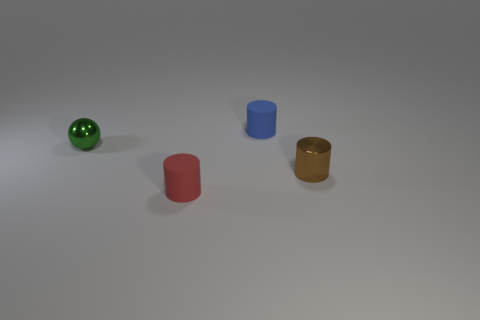How many things are tiny brown objects or rubber cylinders?
Offer a very short reply. 3. The rubber object behind the small red object that is in front of the tiny cylinder that is behind the brown cylinder is what color?
Make the answer very short. Blue. What color is the metal cylinder?
Offer a very short reply. Brown. Is the number of tiny cylinders that are to the left of the green metal object greater than the number of things that are in front of the blue rubber object?
Give a very brief answer. No. There is a blue thing; is its shape the same as the small metallic thing on the left side of the tiny red object?
Give a very brief answer. No. Are there any tiny blue cylinders to the right of the tiny thing that is on the left side of the matte cylinder that is in front of the small green metal thing?
Offer a very short reply. Yes. Are there fewer shiny cylinders that are behind the tiny blue rubber object than tiny cylinders that are in front of the green sphere?
Offer a very short reply. Yes. What is the shape of the small brown object that is made of the same material as the small ball?
Make the answer very short. Cylinder. There is a cylinder on the right side of the small matte thing behind the metal thing that is on the right side of the small red object; what size is it?
Your response must be concise. Small. Are there more green shiny objects than metal things?
Keep it short and to the point. No. 